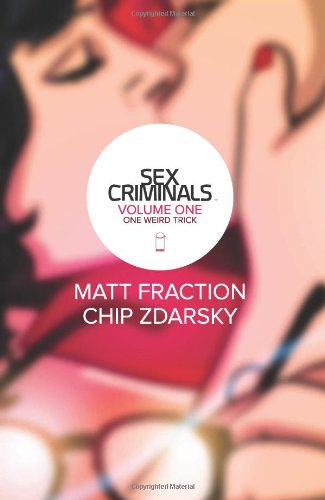Is this a fitness book? No, this book is not related to fitness. It is a graphic novel focused on humorous and mature themes illustrated through comics. 